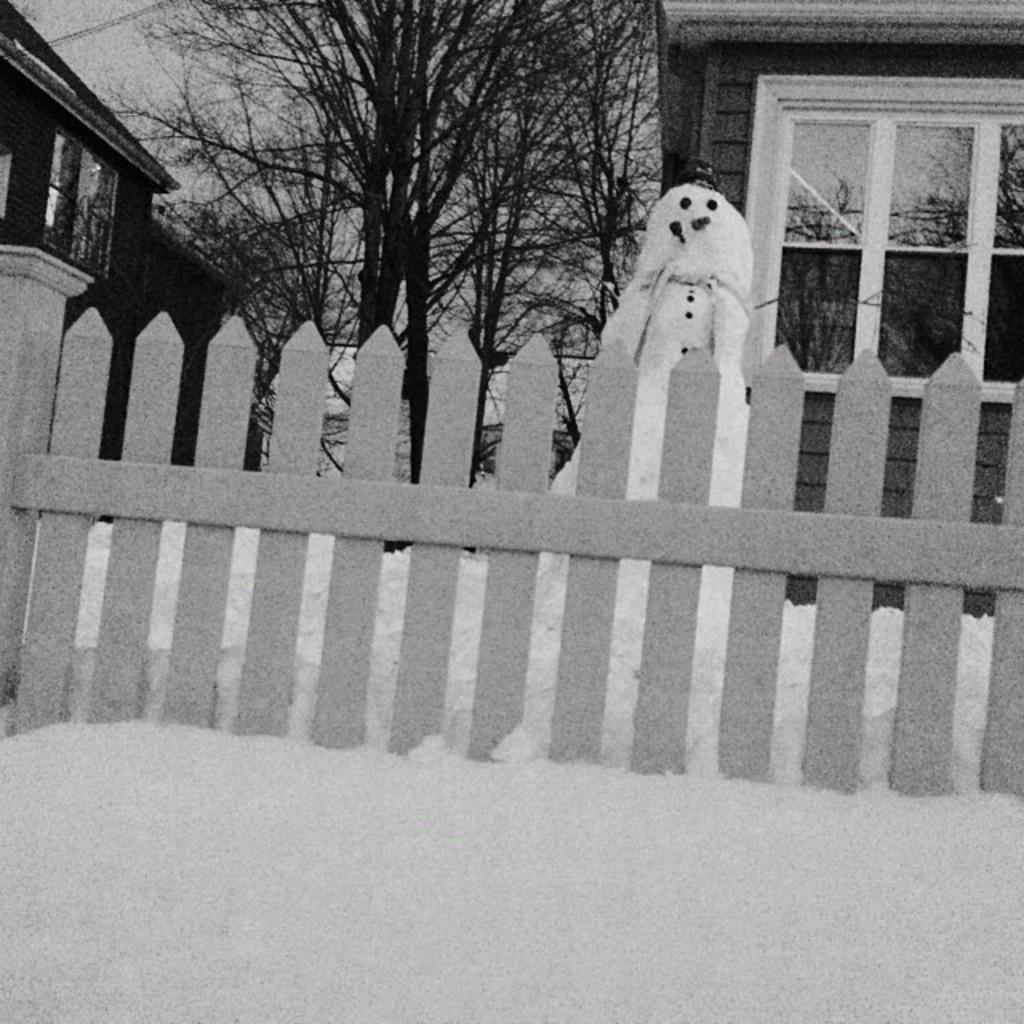What is the color scheme of the image? The image is black and white. What type of structure can be seen in the image? There is a fence in the image. What season might the image represent? The presence of a snowman and snow suggests that the image represents winter. What type of buildings are visible in the image? There are houses with windows in the image. What type of vegetation is present in the image? There are trees with branches in the image. What type of horn can be seen on the snowman in the image? There is no horn present on the snowman in the image. What role does the father play in the image? There is no reference to a father or any people in the image. 